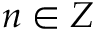<formula> <loc_0><loc_0><loc_500><loc_500>n \in Z</formula> 